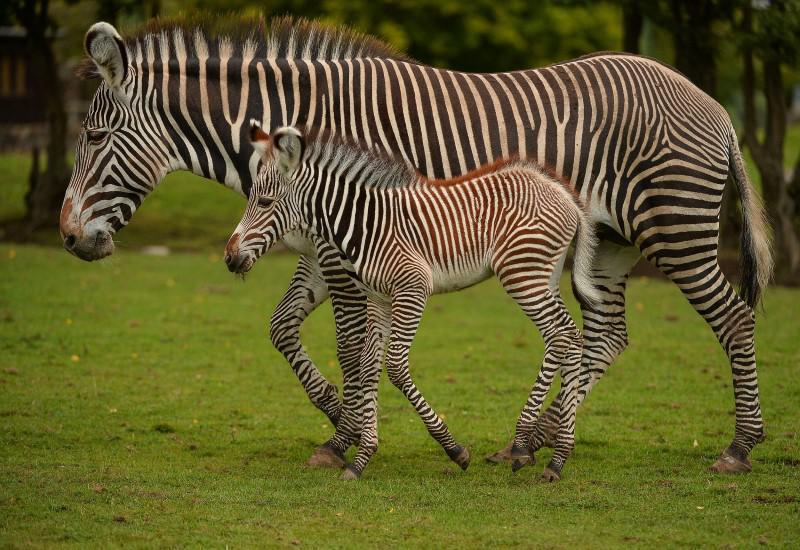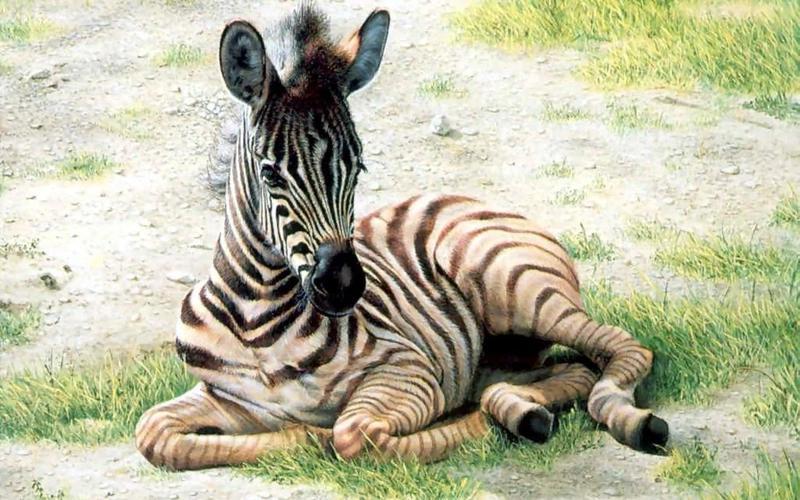The first image is the image on the left, the second image is the image on the right. Examine the images to the left and right. Is the description "The left image shows a zebra colt standing alongside and in front of an adult zebra that faces the same direction, and the right image contains only a zebra colt, which faces forward and is not standing upright." accurate? Answer yes or no. Yes. The first image is the image on the left, the second image is the image on the right. Evaluate the accuracy of this statement regarding the images: "One image has a zebra laying on the ground.". Is it true? Answer yes or no. Yes. 